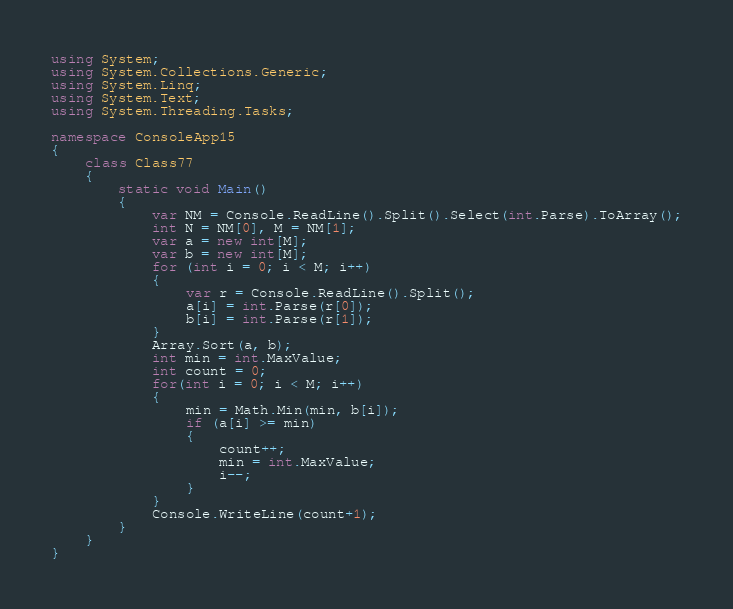Convert code to text. <code><loc_0><loc_0><loc_500><loc_500><_C#_>using System;
using System.Collections.Generic;
using System.Linq;
using System.Text;
using System.Threading.Tasks;

namespace ConsoleApp15
{
    class Class77
    {
        static void Main()
        {
            var NM = Console.ReadLine().Split().Select(int.Parse).ToArray();
            int N = NM[0], M = NM[1];
            var a = new int[M];
            var b = new int[M];
            for (int i = 0; i < M; i++)
            {
                var r = Console.ReadLine().Split();
                a[i] = int.Parse(r[0]);
                b[i] = int.Parse(r[1]);
            }
            Array.Sort(a, b);
            int min = int.MaxValue;
            int count = 0;
            for(int i = 0; i < M; i++)
            {
                min = Math.Min(min, b[i]);
                if (a[i] >= min)
                {
                    count++;
                    min = int.MaxValue;
                    i--;
                }
            }
            Console.WriteLine(count+1);
        }
    }
}
</code> 